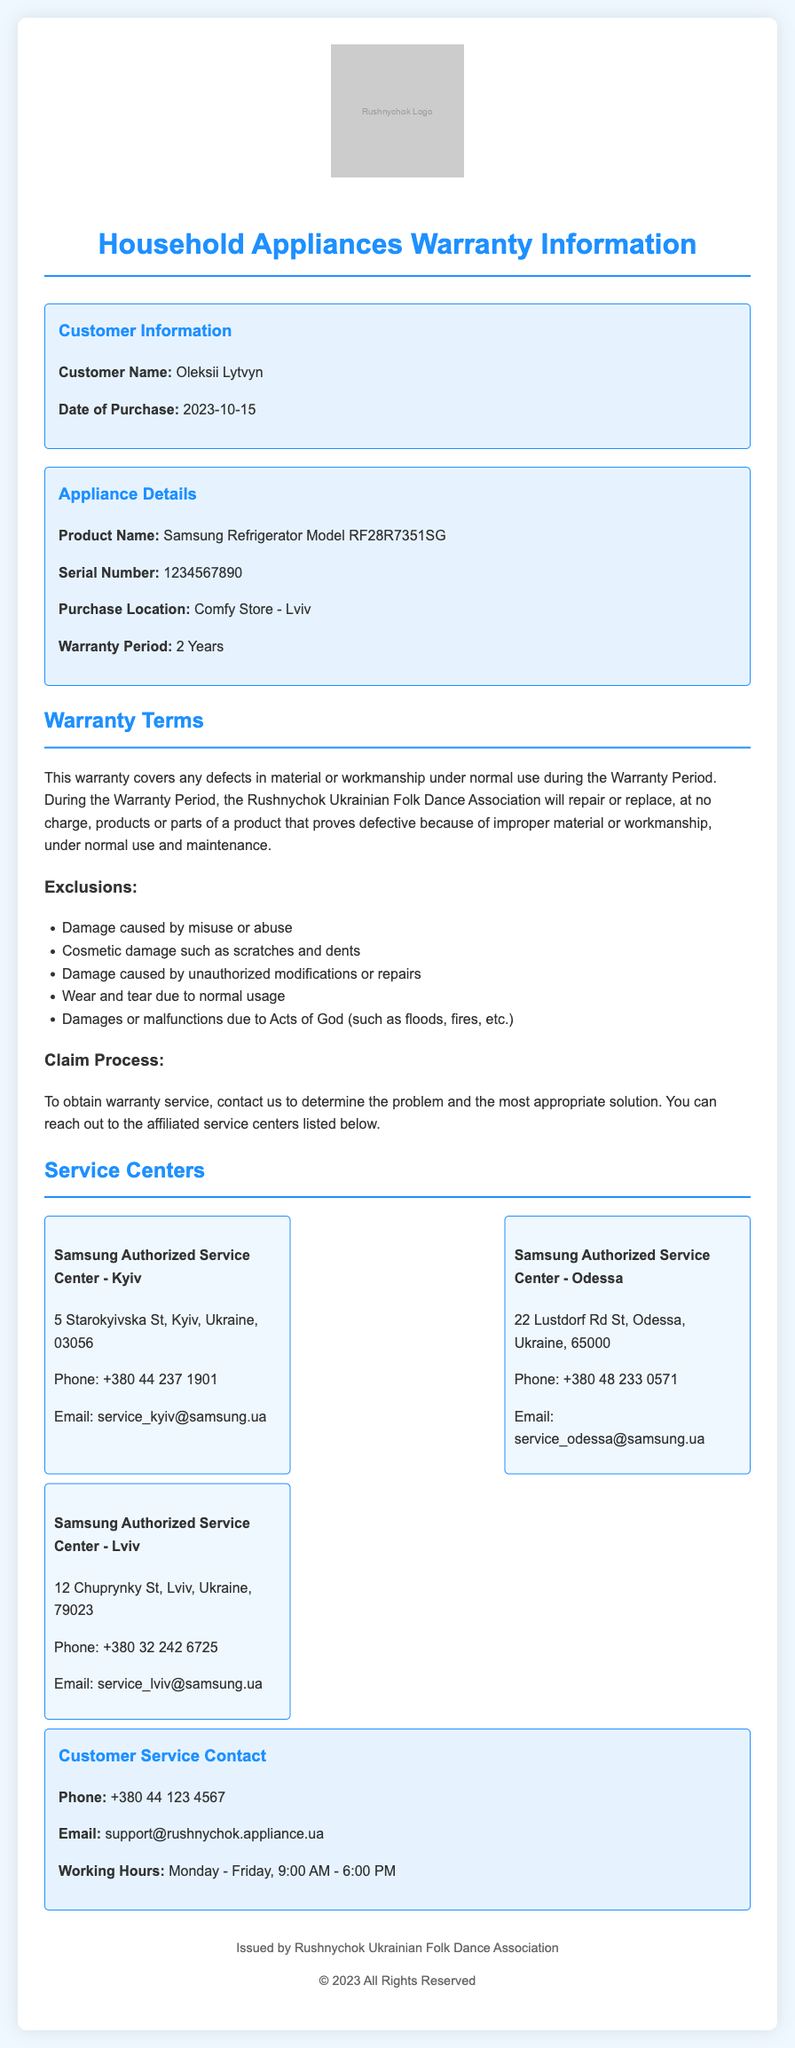what is the customer name? The document specifies the customer's name as Oleksii Lytvyn.
Answer: Oleksii Lytvyn what is the date of purchase? The document provides the purchase date, which is noted clearly as 2023-10-15.
Answer: 2023-10-15 how long is the warranty period for the appliance? The warranty period mentioned for the appliance is 2 years.
Answer: 2 Years what is the serial number of the refrigerator? The document states that the serial number of the refrigerator is 1234567890.
Answer: 1234567890 what are the exclusions in the warranty? The document lists exclusions such as damage caused by misuse or abuse, among others.
Answer: Misuse or abuse how many service centers are listed in the document? The document includes details for three service centers located in different cities.
Answer: 3 which city has a Samsung Authorized Service Center at 5 Starokyivska St? The document specifies that the service center at this address is located in Kyiv.
Answer: Kyiv when can customers contact customer service? The working hours for customer service are Monday - Friday, 9:00 AM - 6:00 PM.
Answer: Monday - Friday, 9:00 AM - 6:00 PM what is the email address for customer service contact? The document provides the email for customer service as support@rushnychok.appliance.ua.
Answer: support@rushnychok.appliance.ua 